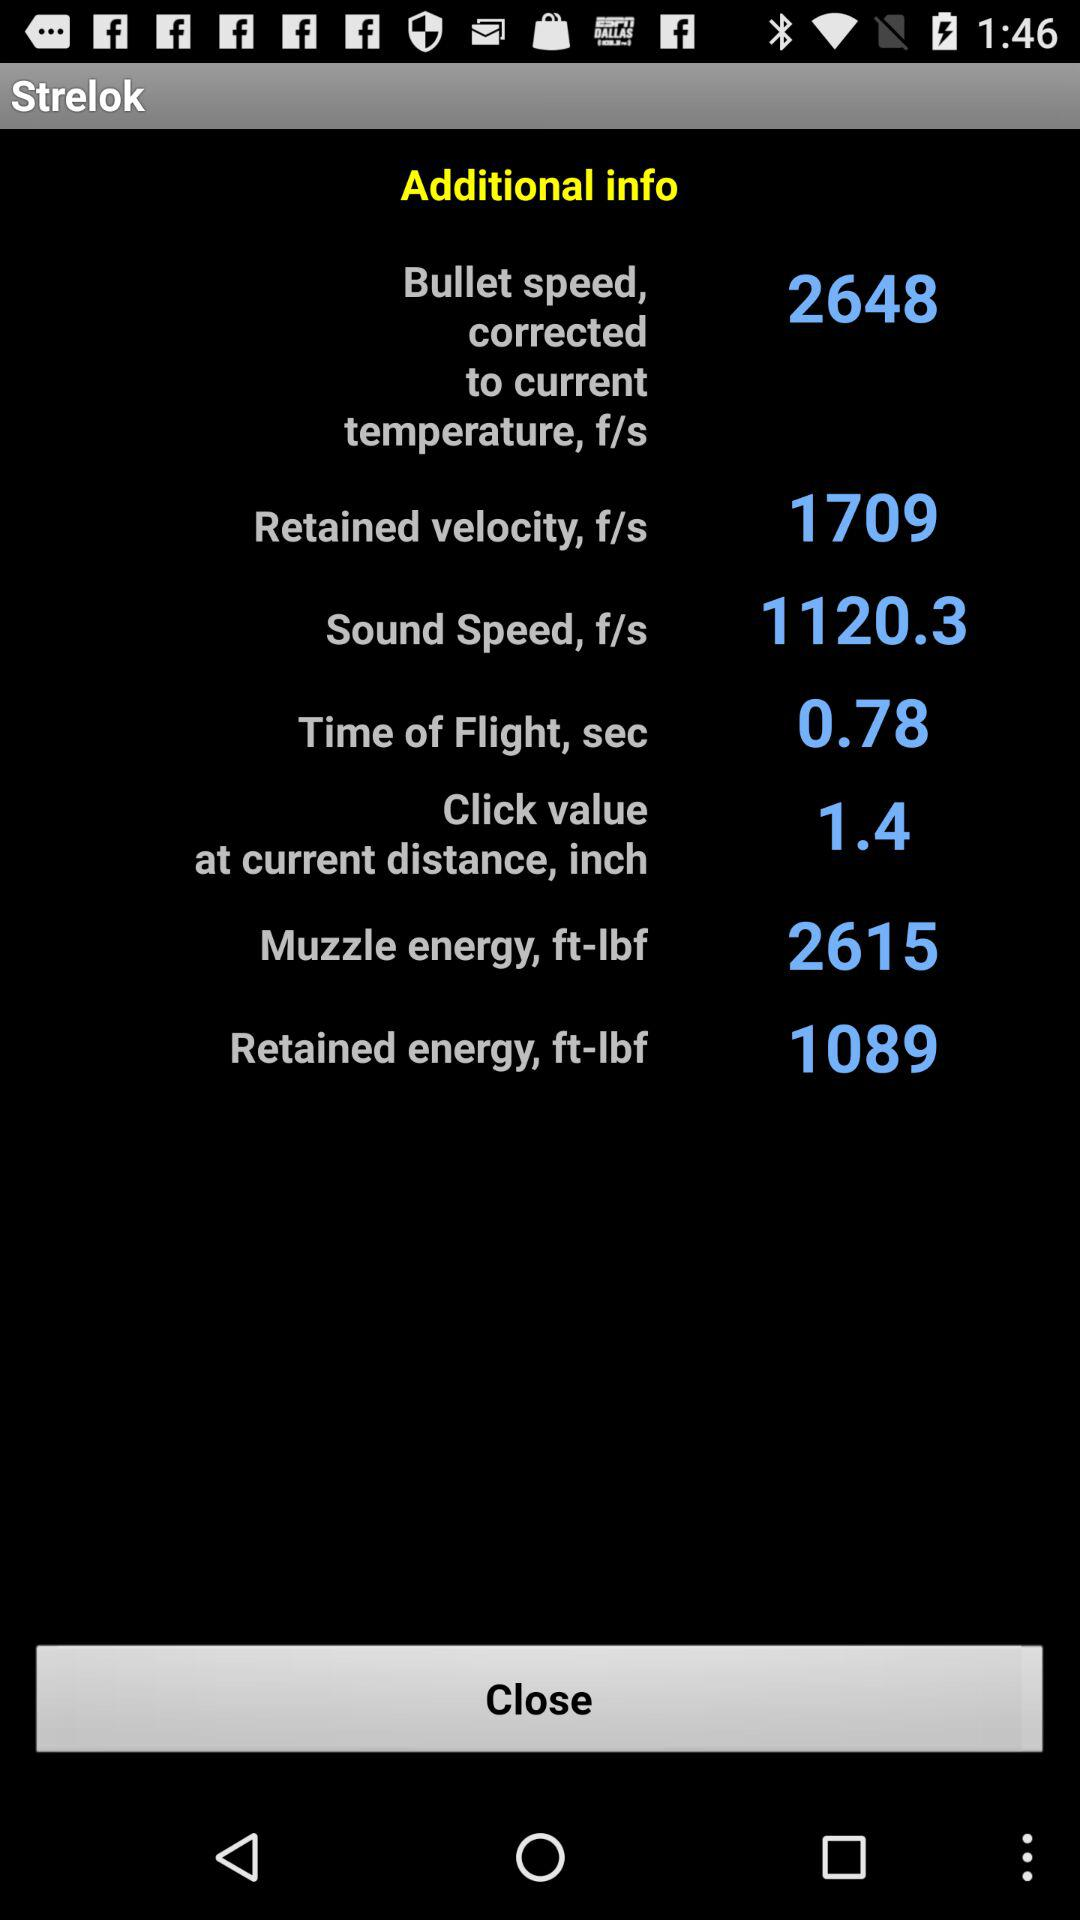What is bullet speed? Bullet speed is 2648. 